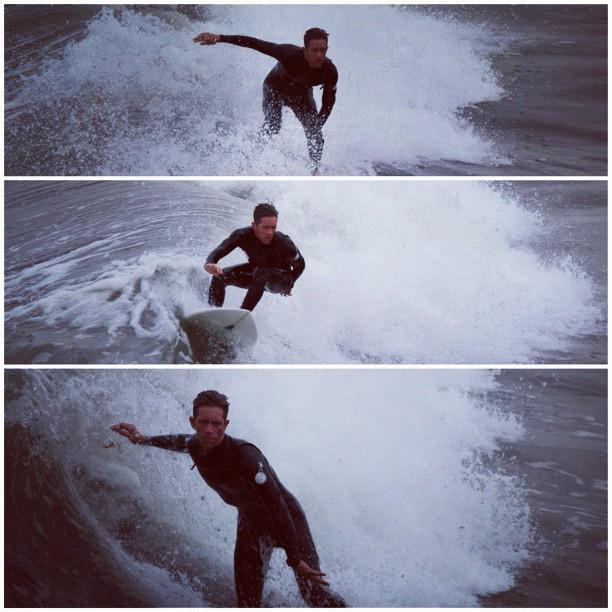How many people are visible?
Give a very brief answer. 3. 